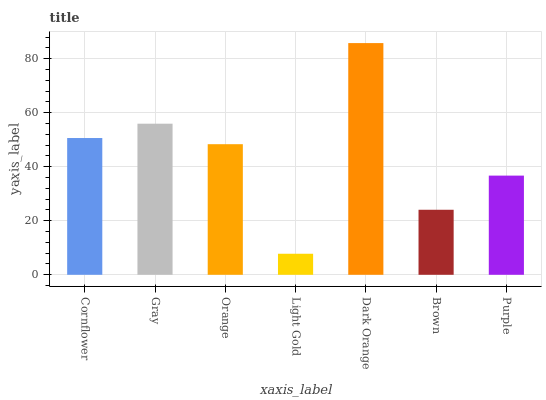Is Light Gold the minimum?
Answer yes or no. Yes. Is Dark Orange the maximum?
Answer yes or no. Yes. Is Gray the minimum?
Answer yes or no. No. Is Gray the maximum?
Answer yes or no. No. Is Gray greater than Cornflower?
Answer yes or no. Yes. Is Cornflower less than Gray?
Answer yes or no. Yes. Is Cornflower greater than Gray?
Answer yes or no. No. Is Gray less than Cornflower?
Answer yes or no. No. Is Orange the high median?
Answer yes or no. Yes. Is Orange the low median?
Answer yes or no. Yes. Is Cornflower the high median?
Answer yes or no. No. Is Brown the low median?
Answer yes or no. No. 